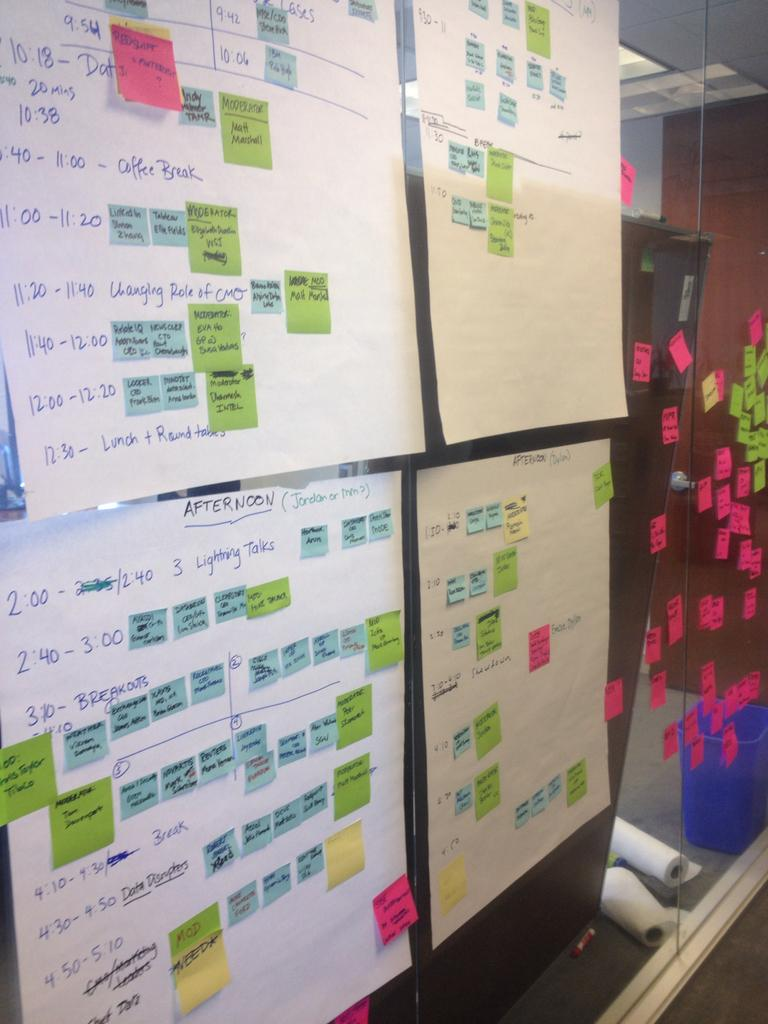<image>
Offer a succinct explanation of the picture presented. Sheets of paper and post it notes are stuck on a glass wall, one of the sheets of paper with the headline Afternoon. 